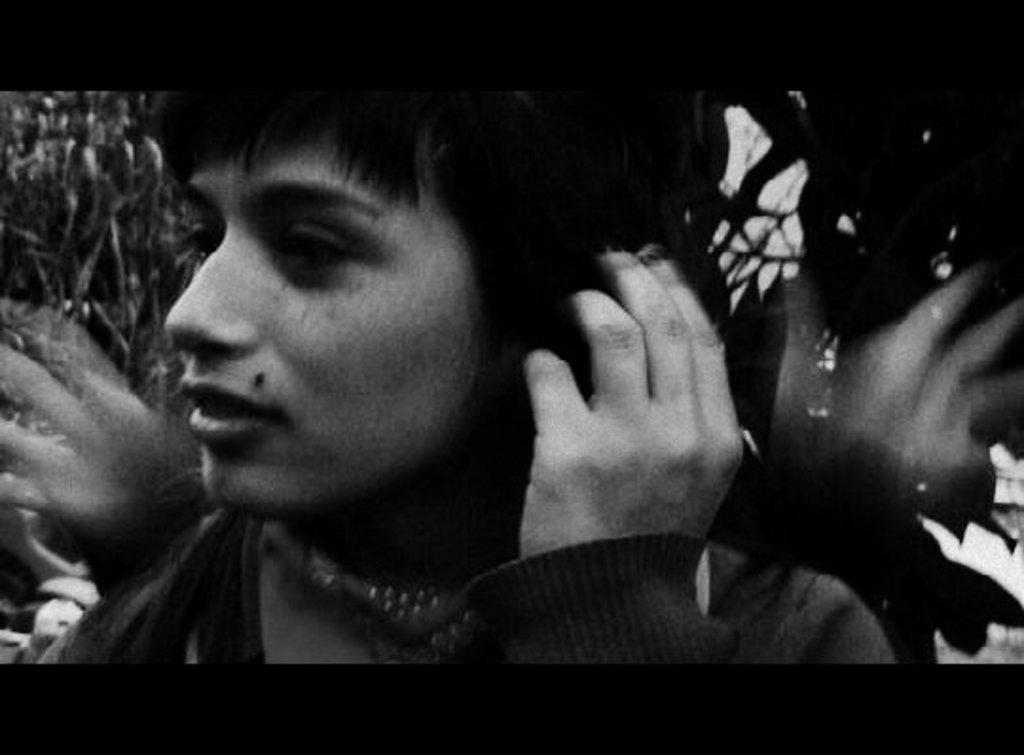Who is present in the image? There is a woman in the image. What is the color scheme of the image? The image is black and white in color. What type of pen is the woman using during recess in the image? There is no pen or recess present in the image; it is a black and white image of a woman. 